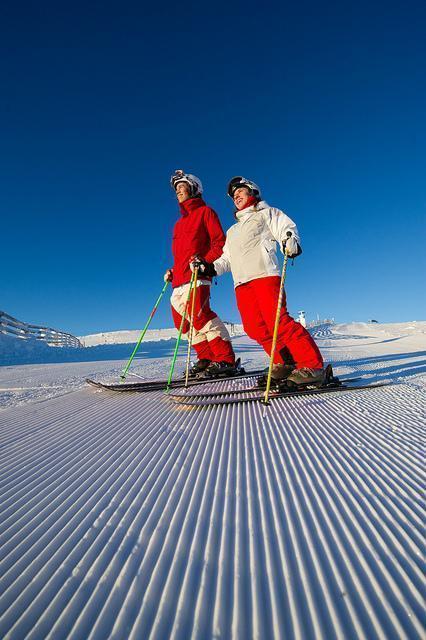How did these grooves get set in snow?
Make your selection and explain in format: 'Answer: answer
Rationale: rationale.'
Options: Natural phenomenon, freak storm, magic, snow groomer. Answer: snow groomer.
Rationale: The grooves are from a grooming machine. 